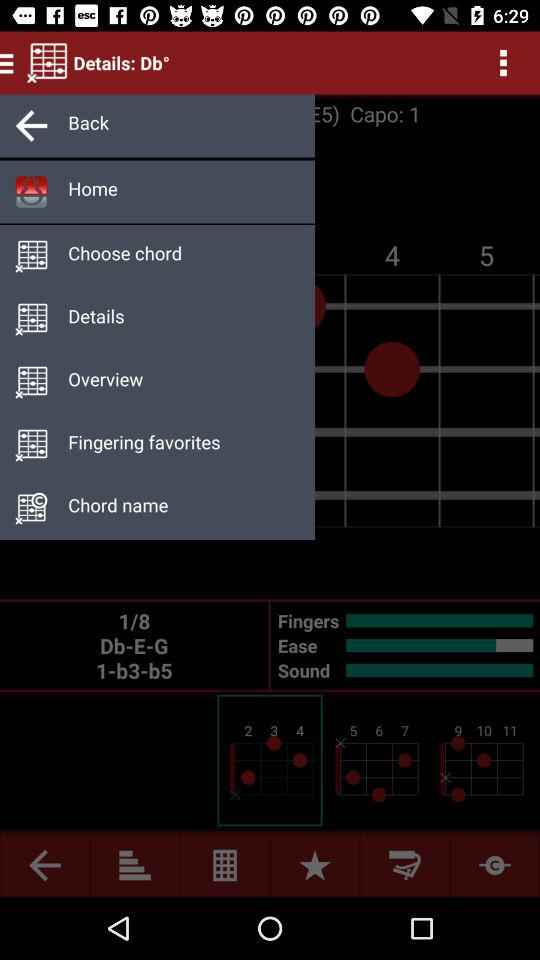What is the app name? The app name is "Details: Db°". 